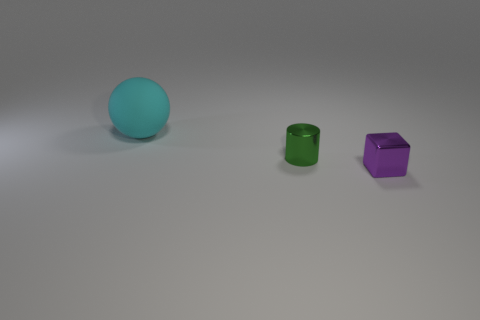Are there any other cyan things of the same shape as the large cyan rubber thing?
Make the answer very short. No. There is a shiny object in front of the small thing to the left of the purple shiny cube that is right of the green metallic cylinder; how big is it?
Your answer should be very brief. Small. Is the number of big cyan matte things that are right of the green thing the same as the number of large objects that are on the left side of the large object?
Your answer should be compact. Yes. What is the size of the green thing that is made of the same material as the purple object?
Give a very brief answer. Small. The matte sphere has what color?
Provide a short and direct response. Cyan. What material is the object that is the same size as the green shiny cylinder?
Give a very brief answer. Metal. There is a metal thing to the right of the tiny cylinder; are there any small cylinders behind it?
Keep it short and to the point. Yes. What number of other objects are the same color as the tiny shiny cylinder?
Your answer should be compact. 0. What size is the ball?
Ensure brevity in your answer.  Large. Are there any small green shiny things?
Ensure brevity in your answer.  Yes. 